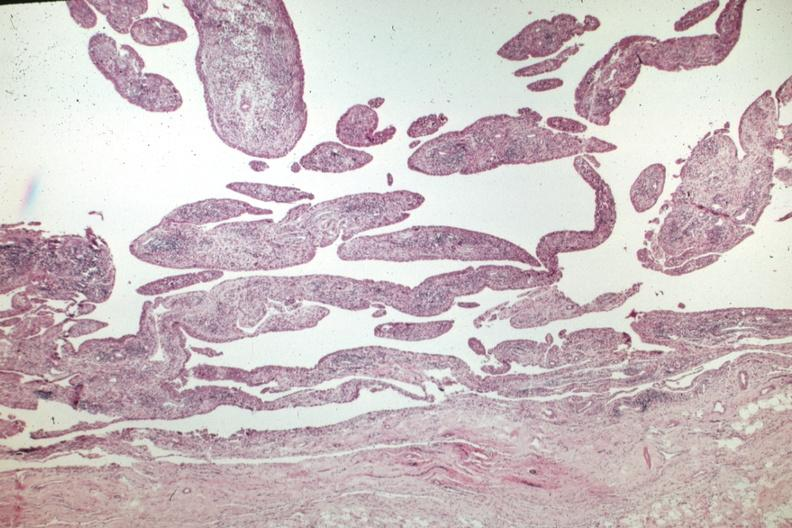how does this image show villous lesion?
Answer the question using a single word or phrase. With chronic inflammatory cells 